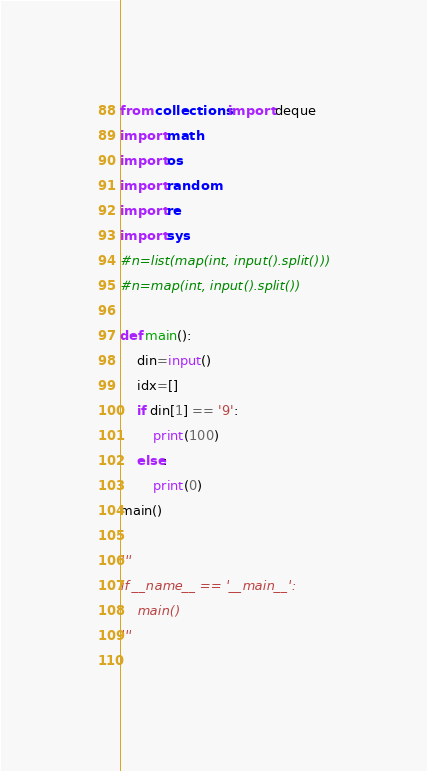Convert code to text. <code><loc_0><loc_0><loc_500><loc_500><_Python_>from collections import deque
import math
import os
import random
import re
import sys
#n=list(map(int, input().split()))
#n=map(int, input().split())

def main():
	din=input()
	idx=[]
	if din[1] == '9':
		print(100)
	else:
		print(0)
main()

'''
if __name__ == '__main__':
    main()
'''
 



</code> 